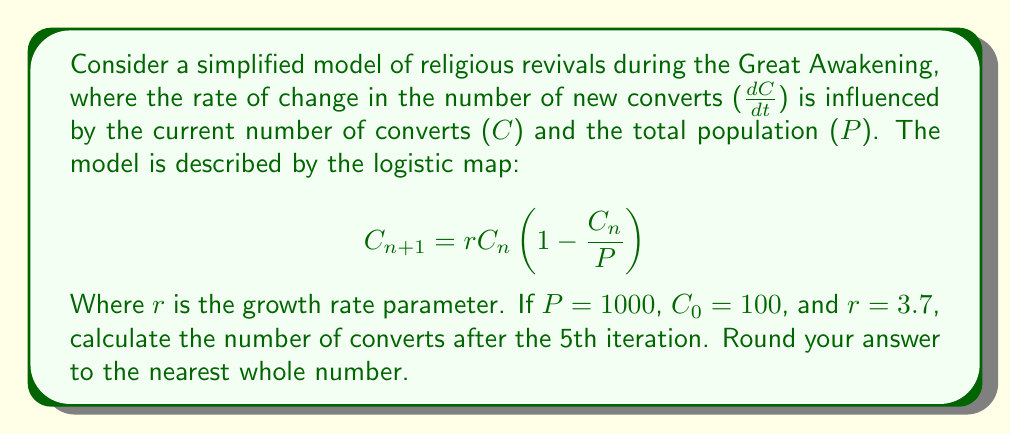Could you help me with this problem? To solve this problem, we need to iterate the logistic map equation five times:

1. Start with $C_0 = 100$ and $P = 1000$

2. First iteration:
   $$C_1 = 3.7 \cdot 100 \cdot (1 - 100/1000) = 333$$

3. Second iteration:
   $$C_2 = 3.7 \cdot 333 \cdot (1 - 333/1000) = 820.47$$

4. Third iteration:
   $$C_3 = 3.7 \cdot 820.47 \cdot (1 - 820.47/1000) = 545.03$$

5. Fourth iteration:
   $$C_4 = 3.7 \cdot 545.03 \cdot (1 - 545.03/1000) = 921.72$$

6. Fifth iteration:
   $$C_5 = 3.7 \cdot 921.72 \cdot (1 - 921.72/1000) = 267.85$$

7. Rounding to the nearest whole number: 268

This demonstrates the chaotic behavior of the logistic map, as the number of converts fluctuates unpredictably over time, mimicking the erratic nature of religious revivals during the Great Awakening.
Answer: 268 